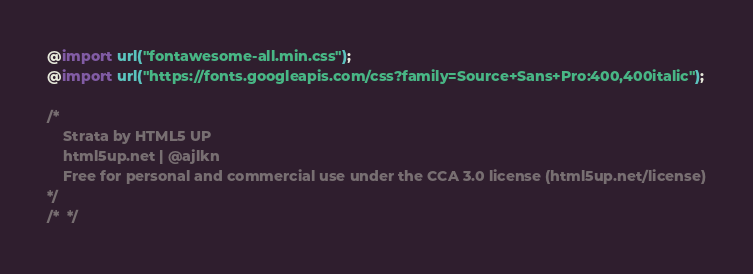<code> <loc_0><loc_0><loc_500><loc_500><_CSS_>@import url("fontawesome-all.min.css");
@import url("https://fonts.googleapis.com/css?family=Source+Sans+Pro:400,400italic");

/*
	Strata by HTML5 UP
	html5up.net | @ajlkn
	Free for personal and commercial use under the CCA 3.0 license (html5up.net/license)
*/
/*  */</code> 